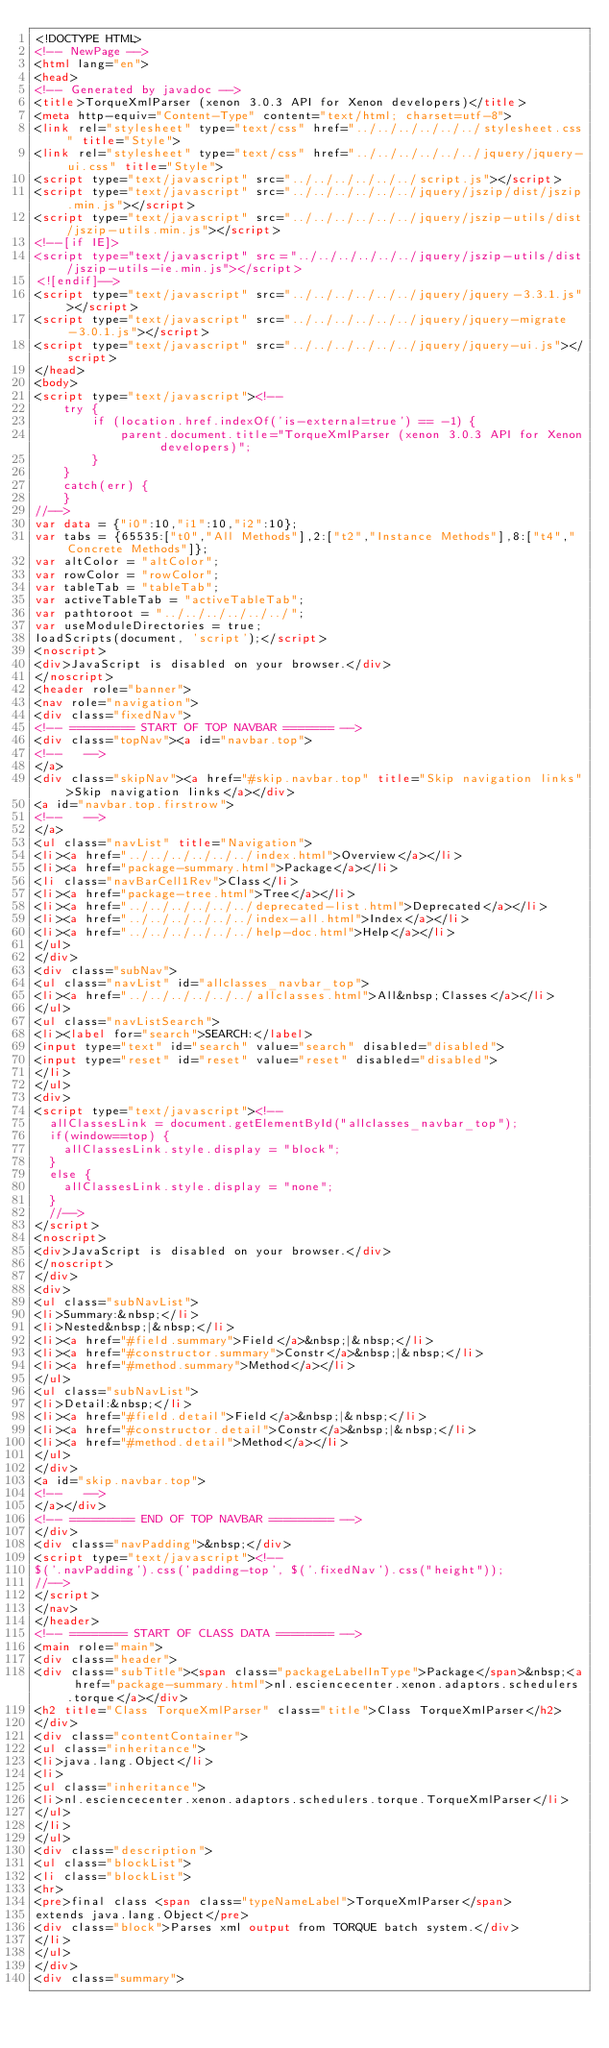Convert code to text. <code><loc_0><loc_0><loc_500><loc_500><_HTML_><!DOCTYPE HTML>
<!-- NewPage -->
<html lang="en">
<head>
<!-- Generated by javadoc -->
<title>TorqueXmlParser (xenon 3.0.3 API for Xenon developers)</title>
<meta http-equiv="Content-Type" content="text/html; charset=utf-8">
<link rel="stylesheet" type="text/css" href="../../../../../../stylesheet.css" title="Style">
<link rel="stylesheet" type="text/css" href="../../../../../../jquery/jquery-ui.css" title="Style">
<script type="text/javascript" src="../../../../../../script.js"></script>
<script type="text/javascript" src="../../../../../../jquery/jszip/dist/jszip.min.js"></script>
<script type="text/javascript" src="../../../../../../jquery/jszip-utils/dist/jszip-utils.min.js"></script>
<!--[if IE]>
<script type="text/javascript" src="../../../../../../jquery/jszip-utils/dist/jszip-utils-ie.min.js"></script>
<![endif]-->
<script type="text/javascript" src="../../../../../../jquery/jquery-3.3.1.js"></script>
<script type="text/javascript" src="../../../../../../jquery/jquery-migrate-3.0.1.js"></script>
<script type="text/javascript" src="../../../../../../jquery/jquery-ui.js"></script>
</head>
<body>
<script type="text/javascript"><!--
    try {
        if (location.href.indexOf('is-external=true') == -1) {
            parent.document.title="TorqueXmlParser (xenon 3.0.3 API for Xenon developers)";
        }
    }
    catch(err) {
    }
//-->
var data = {"i0":10,"i1":10,"i2":10};
var tabs = {65535:["t0","All Methods"],2:["t2","Instance Methods"],8:["t4","Concrete Methods"]};
var altColor = "altColor";
var rowColor = "rowColor";
var tableTab = "tableTab";
var activeTableTab = "activeTableTab";
var pathtoroot = "../../../../../../";
var useModuleDirectories = true;
loadScripts(document, 'script');</script>
<noscript>
<div>JavaScript is disabled on your browser.</div>
</noscript>
<header role="banner">
<nav role="navigation">
<div class="fixedNav">
<!-- ========= START OF TOP NAVBAR ======= -->
<div class="topNav"><a id="navbar.top">
<!--   -->
</a>
<div class="skipNav"><a href="#skip.navbar.top" title="Skip navigation links">Skip navigation links</a></div>
<a id="navbar.top.firstrow">
<!--   -->
</a>
<ul class="navList" title="Navigation">
<li><a href="../../../../../../index.html">Overview</a></li>
<li><a href="package-summary.html">Package</a></li>
<li class="navBarCell1Rev">Class</li>
<li><a href="package-tree.html">Tree</a></li>
<li><a href="../../../../../../deprecated-list.html">Deprecated</a></li>
<li><a href="../../../../../../index-all.html">Index</a></li>
<li><a href="../../../../../../help-doc.html">Help</a></li>
</ul>
</div>
<div class="subNav">
<ul class="navList" id="allclasses_navbar_top">
<li><a href="../../../../../../allclasses.html">All&nbsp;Classes</a></li>
</ul>
<ul class="navListSearch">
<li><label for="search">SEARCH:</label>
<input type="text" id="search" value="search" disabled="disabled">
<input type="reset" id="reset" value="reset" disabled="disabled">
</li>
</ul>
<div>
<script type="text/javascript"><!--
  allClassesLink = document.getElementById("allclasses_navbar_top");
  if(window==top) {
    allClassesLink.style.display = "block";
  }
  else {
    allClassesLink.style.display = "none";
  }
  //-->
</script>
<noscript>
<div>JavaScript is disabled on your browser.</div>
</noscript>
</div>
<div>
<ul class="subNavList">
<li>Summary:&nbsp;</li>
<li>Nested&nbsp;|&nbsp;</li>
<li><a href="#field.summary">Field</a>&nbsp;|&nbsp;</li>
<li><a href="#constructor.summary">Constr</a>&nbsp;|&nbsp;</li>
<li><a href="#method.summary">Method</a></li>
</ul>
<ul class="subNavList">
<li>Detail:&nbsp;</li>
<li><a href="#field.detail">Field</a>&nbsp;|&nbsp;</li>
<li><a href="#constructor.detail">Constr</a>&nbsp;|&nbsp;</li>
<li><a href="#method.detail">Method</a></li>
</ul>
</div>
<a id="skip.navbar.top">
<!--   -->
</a></div>
<!-- ========= END OF TOP NAVBAR ========= -->
</div>
<div class="navPadding">&nbsp;</div>
<script type="text/javascript"><!--
$('.navPadding').css('padding-top', $('.fixedNav').css("height"));
//-->
</script>
</nav>
</header>
<!-- ======== START OF CLASS DATA ======== -->
<main role="main">
<div class="header">
<div class="subTitle"><span class="packageLabelInType">Package</span>&nbsp;<a href="package-summary.html">nl.esciencecenter.xenon.adaptors.schedulers.torque</a></div>
<h2 title="Class TorqueXmlParser" class="title">Class TorqueXmlParser</h2>
</div>
<div class="contentContainer">
<ul class="inheritance">
<li>java.lang.Object</li>
<li>
<ul class="inheritance">
<li>nl.esciencecenter.xenon.adaptors.schedulers.torque.TorqueXmlParser</li>
</ul>
</li>
</ul>
<div class="description">
<ul class="blockList">
<li class="blockList">
<hr>
<pre>final class <span class="typeNameLabel">TorqueXmlParser</span>
extends java.lang.Object</pre>
<div class="block">Parses xml output from TORQUE batch system.</div>
</li>
</ul>
</div>
<div class="summary"></code> 